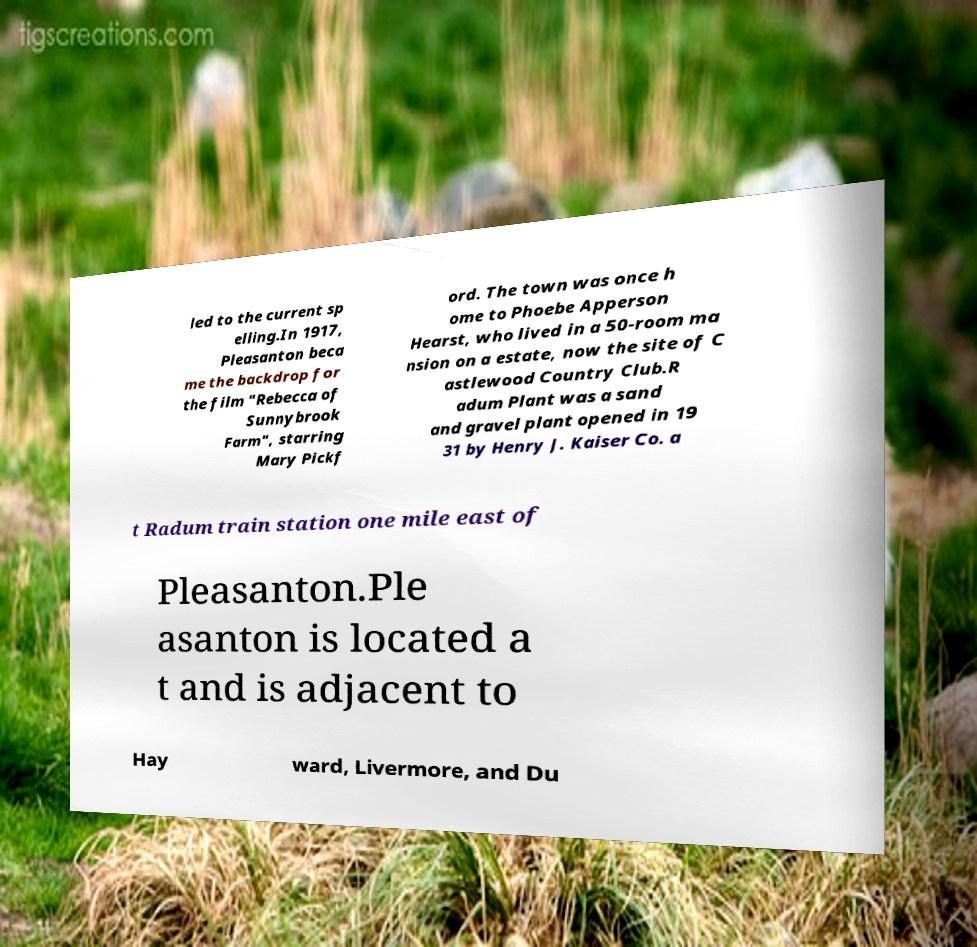Please read and relay the text visible in this image. What does it say? led to the current sp elling.In 1917, Pleasanton beca me the backdrop for the film "Rebecca of Sunnybrook Farm", starring Mary Pickf ord. The town was once h ome to Phoebe Apperson Hearst, who lived in a 50-room ma nsion on a estate, now the site of C astlewood Country Club.R adum Plant was a sand and gravel plant opened in 19 31 by Henry J. Kaiser Co. a t Radum train station one mile east of Pleasanton.Ple asanton is located a t and is adjacent to Hay ward, Livermore, and Du 